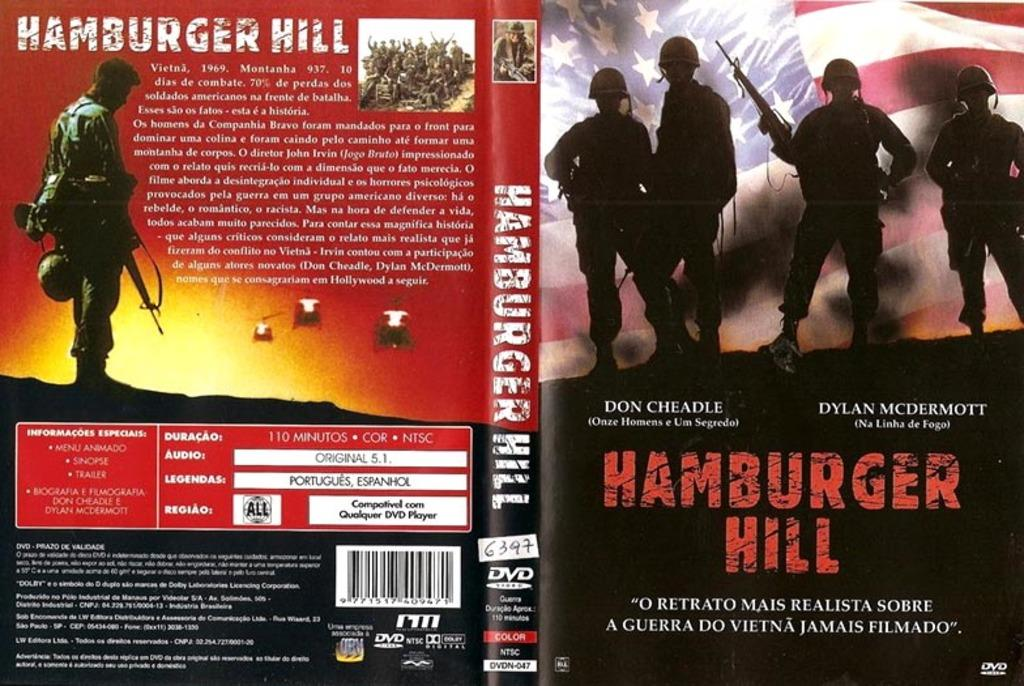<image>
Give a short and clear explanation of the subsequent image. A book cover for Hamburger Hill including the back of the book. 